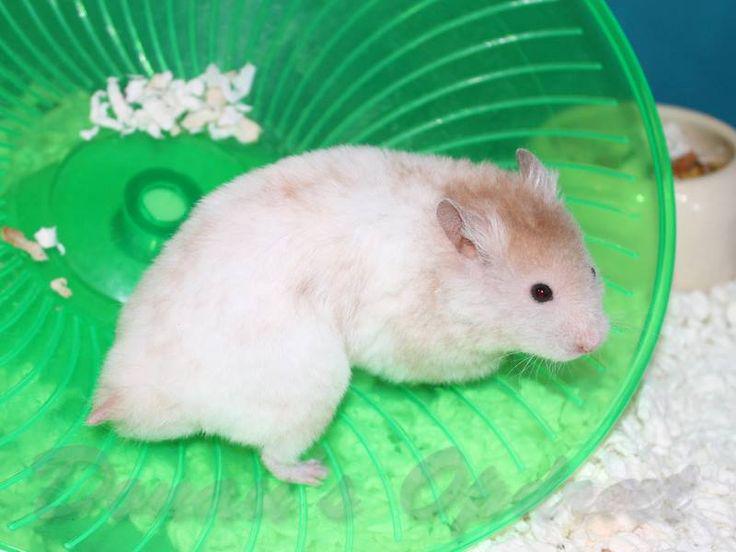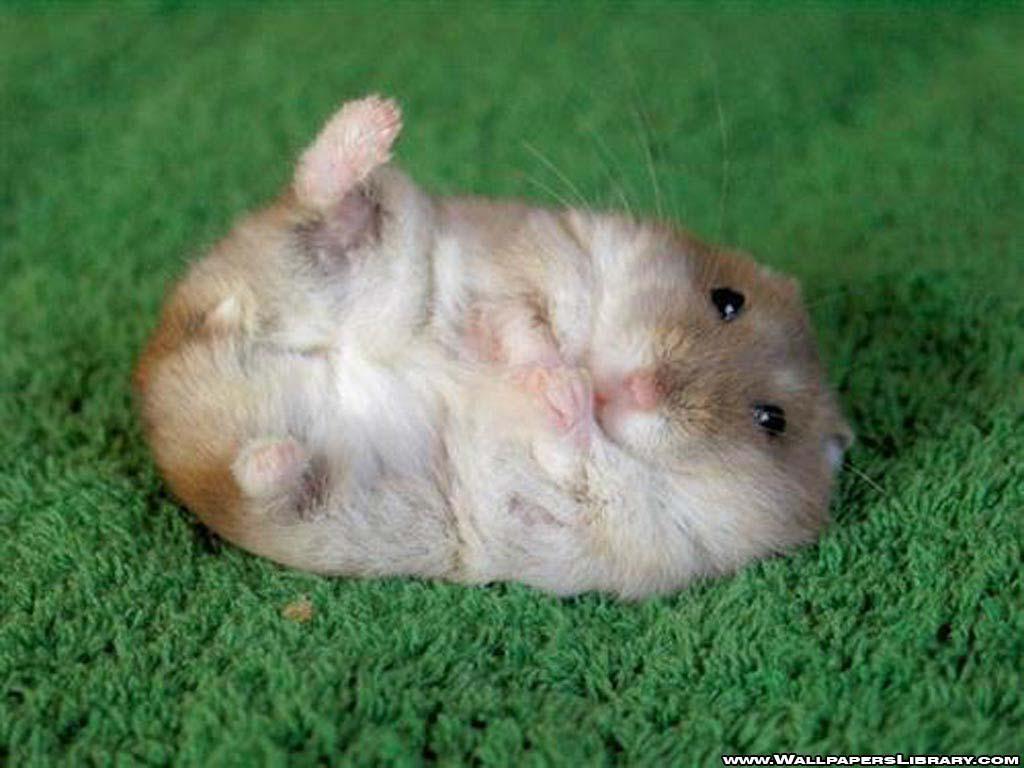The first image is the image on the left, the second image is the image on the right. Considering the images on both sides, is "Each image shows at least one hamster on a green surface, and at least one image shows a hamster in a round green plastic object." valid? Answer yes or no. Yes. The first image is the image on the left, the second image is the image on the right. Given the left and right images, does the statement "At least one hamster is swimming in the water." hold true? Answer yes or no. No. 